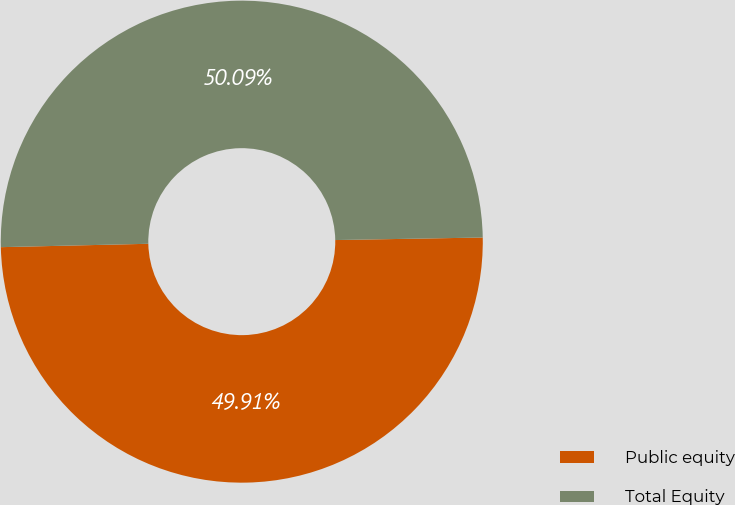<chart> <loc_0><loc_0><loc_500><loc_500><pie_chart><fcel>Public equity<fcel>Total Equity<nl><fcel>49.91%<fcel>50.09%<nl></chart> 